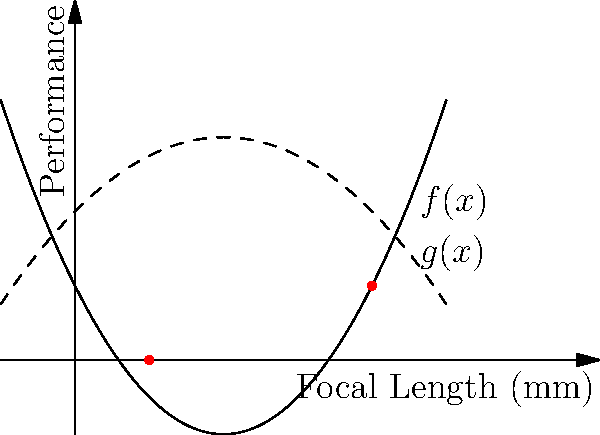Deux courbes polynomiales, $f(x) = 0.5x^2 - 2x + 1$ et $g(x) = -0.25x^2 + x + 2$, représentent la performance de deux objectifs photographiques en fonction de leur longueur focale. Déterminez les points d'intersection de ces courbes et interprétez leur signification pour un photographe. Pour trouver les points d'intersection, nous devons résoudre l'équation $f(x) = g(x)$ :

1) $0.5x^2 - 2x + 1 = -0.25x^2 + x + 2$

2) Réorganisons l'équation :
   $0.5x^2 + 0.25x^2 - 2x - x + 1 - 2 = 0$
   $0.75x^2 - 3x - 1 = 0$

3) Multiplions par 4 pour simplifier les fractions :
   $3x^2 - 12x - 4 = 0$

4) Utilisons la formule quadratique $x = \frac{-b \pm \sqrt{b^2 - 4ac}}{2a}$ :
   $a = 3, b = -12, c = -4$
   $x = \frac{12 \pm \sqrt{144 + 48}}{6} = \frac{12 \pm \sqrt{192}}{6} = \frac{12 \pm 8\sqrt{3}}{6}$

5) Simplifions :
   $x_1 = \frac{12 + 8\sqrt{3}}{6} = 2 + \frac{4\sqrt{3}}{3} \approx 4$
   $x_2 = \frac{12 - 8\sqrt{3}}{6} = 2 - \frac{4\sqrt{3}}{3} \approx 1$

6) Vérifions les valeurs de y :
   Pour $x_1 \approx 4$ : $f(4) = g(4) = 1$
   Pour $x_2 \approx 1$ : $f(1) = g(1) = 0$

Interprétation : Les points d'intersection (1,0) et (4,1) indiquent les longueurs focales où les deux objectifs ont des performances équivalentes. Un photographe pourrait choisir l'objectif le plus performant pour les autres longueurs focales selon la courbe la plus élevée.
Answer: (1,0) et (4,1) 